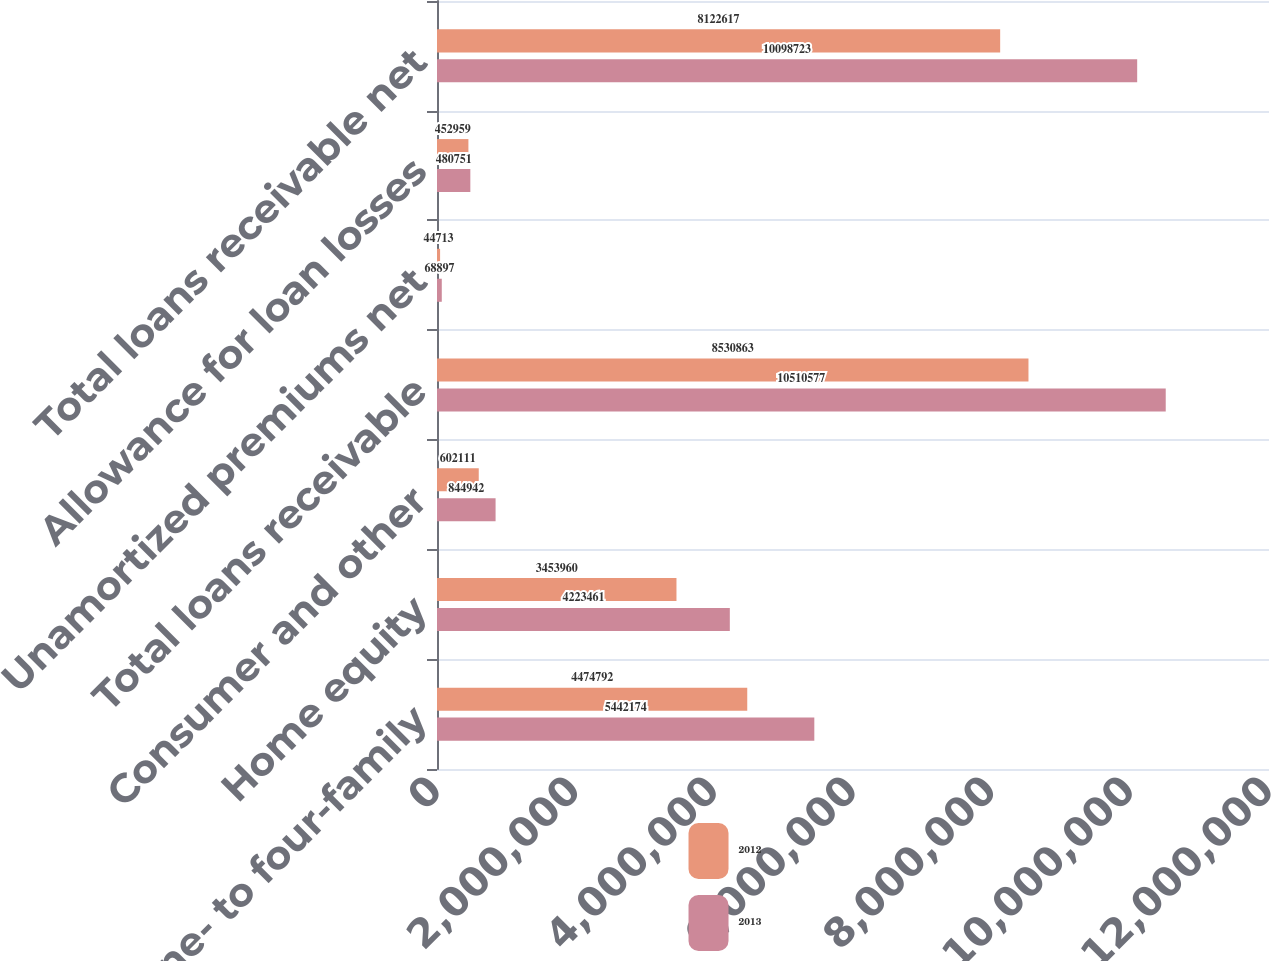Convert chart. <chart><loc_0><loc_0><loc_500><loc_500><stacked_bar_chart><ecel><fcel>One- to four-family<fcel>Home equity<fcel>Consumer and other<fcel>Total loans receivable<fcel>Unamortized premiums net<fcel>Allowance for loan losses<fcel>Total loans receivable net<nl><fcel>2012<fcel>4.47479e+06<fcel>3.45396e+06<fcel>602111<fcel>8.53086e+06<fcel>44713<fcel>452959<fcel>8.12262e+06<nl><fcel>2013<fcel>5.44217e+06<fcel>4.22346e+06<fcel>844942<fcel>1.05106e+07<fcel>68897<fcel>480751<fcel>1.00987e+07<nl></chart> 